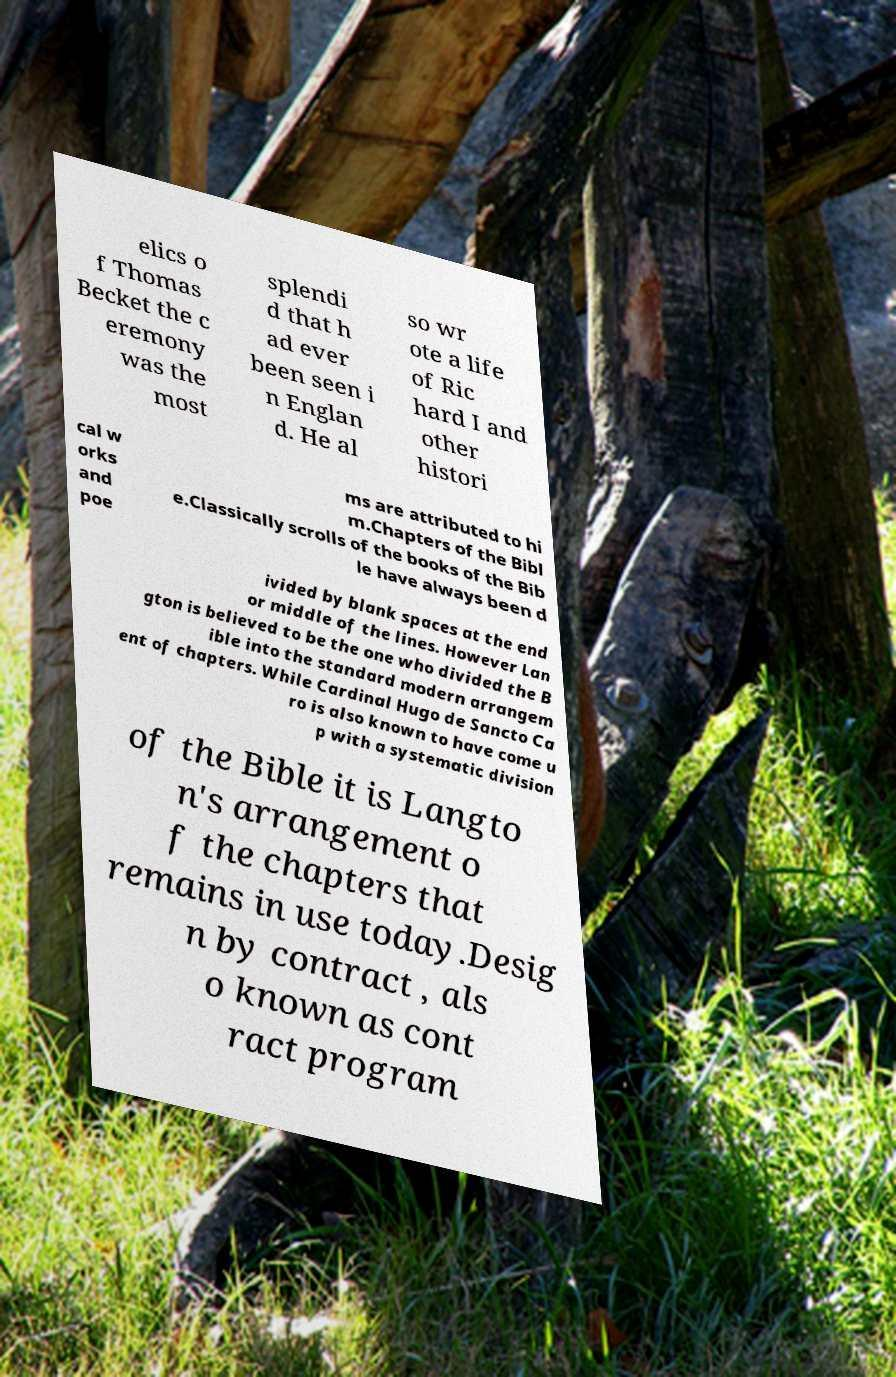Can you accurately transcribe the text from the provided image for me? elics o f Thomas Becket the c eremony was the most splendi d that h ad ever been seen i n Englan d. He al so wr ote a life of Ric hard I and other histori cal w orks and poe ms are attributed to hi m.Chapters of the Bibl e.Classically scrolls of the books of the Bib le have always been d ivided by blank spaces at the end or middle of the lines. However Lan gton is believed to be the one who divided the B ible into the standard modern arrangem ent of chapters. While Cardinal Hugo de Sancto Ca ro is also known to have come u p with a systematic division of the Bible it is Langto n's arrangement o f the chapters that remains in use today.Desig n by contract , als o known as cont ract program 